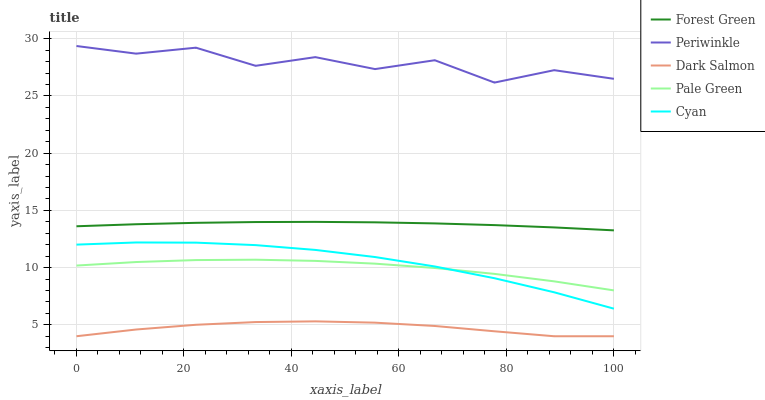Does Dark Salmon have the minimum area under the curve?
Answer yes or no. Yes. Does Periwinkle have the maximum area under the curve?
Answer yes or no. Yes. Does Forest Green have the minimum area under the curve?
Answer yes or no. No. Does Forest Green have the maximum area under the curve?
Answer yes or no. No. Is Forest Green the smoothest?
Answer yes or no. Yes. Is Periwinkle the roughest?
Answer yes or no. Yes. Is Pale Green the smoothest?
Answer yes or no. No. Is Pale Green the roughest?
Answer yes or no. No. Does Dark Salmon have the lowest value?
Answer yes or no. Yes. Does Forest Green have the lowest value?
Answer yes or no. No. Does Periwinkle have the highest value?
Answer yes or no. Yes. Does Forest Green have the highest value?
Answer yes or no. No. Is Forest Green less than Periwinkle?
Answer yes or no. Yes. Is Periwinkle greater than Pale Green?
Answer yes or no. Yes. Does Cyan intersect Pale Green?
Answer yes or no. Yes. Is Cyan less than Pale Green?
Answer yes or no. No. Is Cyan greater than Pale Green?
Answer yes or no. No. Does Forest Green intersect Periwinkle?
Answer yes or no. No. 